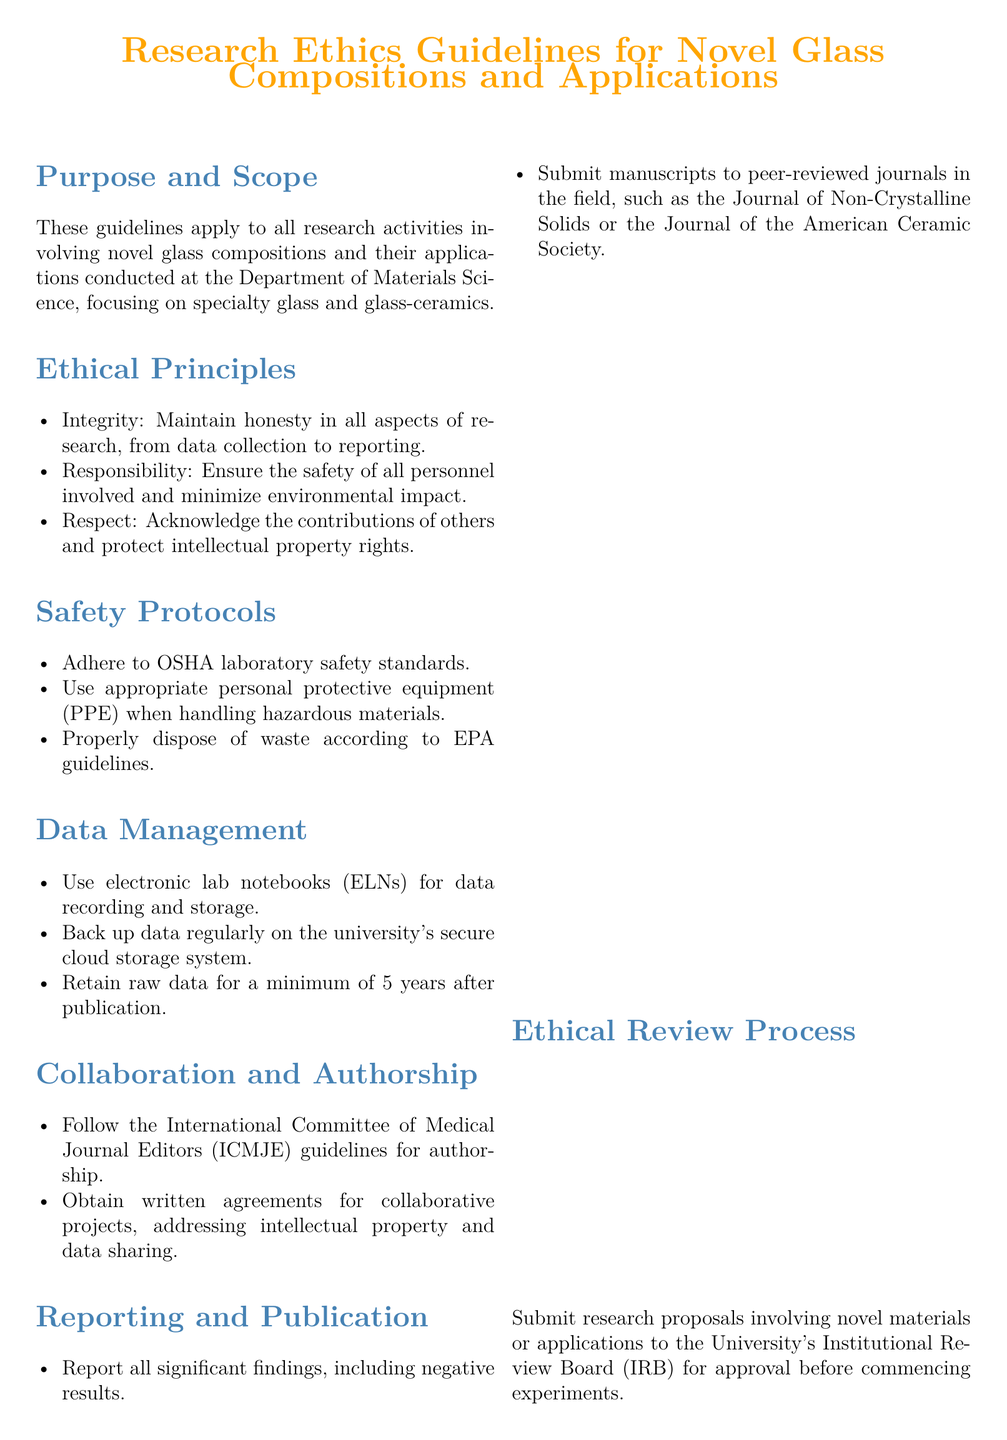What is the effective date of the guidelines? The effective date is stated in the document as the starting point for the implementation of the guidelines.
Answer: September 1, 2023 What principle emphasizes honesty in research? The principle that focuses on honesty in all aspects of research is listed under ethical principles in the document.
Answer: Integrity Which safety standards must be adhered to? The document specifies which safety standards researchers must follow when conducting experiments in the lab.
Answer: OSHA laboratory safety standards How long must raw data be retained after publication? The document indicates a specific duration for retaining raw data, crucial for reference and verification.
Answer: 5 years What must be submitted for approval before commencing experiments? The document highlights an essential step in the research process that requires formal approval from a governing body.
Answer: Research proposals Which journal is mentioned for submitting manuscripts? The document provides examples of journals where research findings should be submitted for publication.
Answer: Journal of Non-Crystalline Solids What is the primary purpose of these guidelines? The document outlines the main goal of establishing standards for research activities involving new materials.
Answer: To apply to all research activities involving novel glass compositions and their applications What type of agreement is required for collaborative projects? The guidelines state the necessity for written agreements in research partnerships addressing specific aspects of collaboration.
Answer: Written agreements 